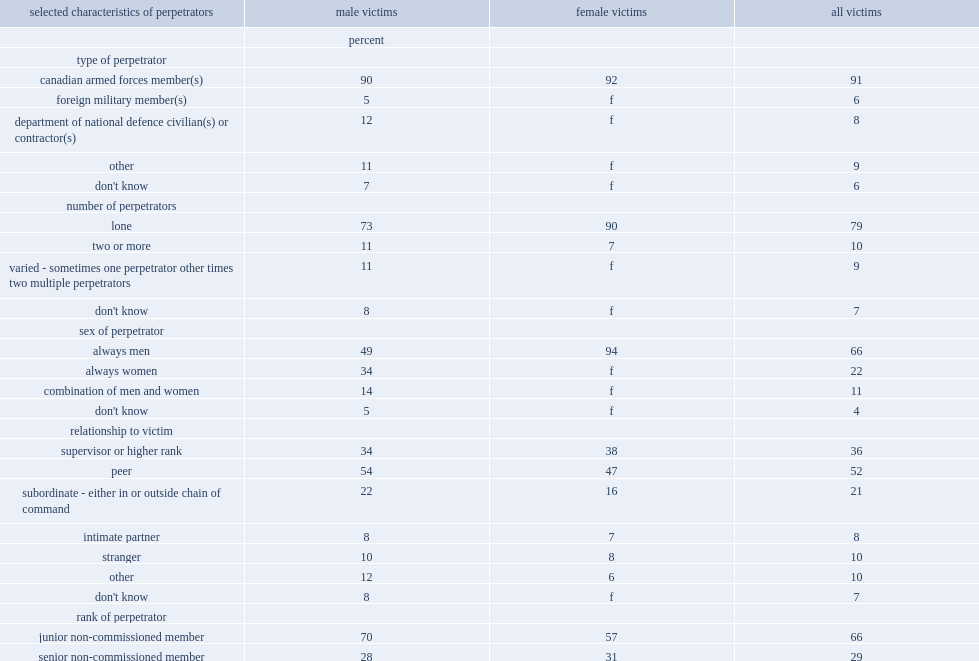What is the most common type of perpetrator? Type of perpetrator. What is the most common number of perpetrators? Number of perpetrators. What is the most common sex of perpetrators? Always men. What is the most common rank of perpetrator? Junior non-commissioned member. What is ratio of caf members to the perpetrators? 91.0. Whar is the proportion of victims who reported that perpetrators are department of national defence (dnd) civilians or contractor? 8.0. Whar is the proportion of victims who reported that perpetrators are foreign military members? 6.0. Which gender is more likely to be assaulted by a perpetrater acting alone? Female victims. What is the proportion of victims who said that the perpetrators were always men? 66.0. What is the proportion of victims who stated that their assault involved both male and female perpetrators? 11.0. What is the proportion of male victims who reported their perpetrater was a men? 49.0. What is the proportion of female victims who reported their perpetrater was a men? 94.0. What is the proportion of male victims who stated the perpetrator was a woman? 34.0. 